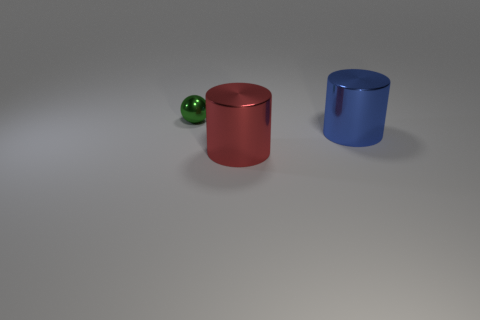What number of other objects are there of the same color as the tiny ball?
Provide a succinct answer. 0. Are there more large shiny objects to the left of the large blue thing than tiny green spheres on the right side of the small green shiny sphere?
Make the answer very short. Yes. Is there a blue object of the same shape as the big red thing?
Your answer should be compact. Yes. Is the size of the cylinder that is on the right side of the red shiny cylinder the same as the green ball?
Offer a terse response. No. Are any large gray rubber cylinders visible?
Keep it short and to the point. No. How many objects are cylinders on the left side of the big blue cylinder or gray shiny cylinders?
Your answer should be compact. 1. Is there a red metal cylinder that has the same size as the blue thing?
Keep it short and to the point. Yes. What shape is the small green object that is the same material as the red thing?
Ensure brevity in your answer.  Sphere. What is the size of the cylinder that is behind the large red shiny cylinder?
Make the answer very short. Large. Are there the same number of blue metallic cylinders to the right of the large blue shiny object and blue things to the right of the big red metallic object?
Provide a short and direct response. No. 